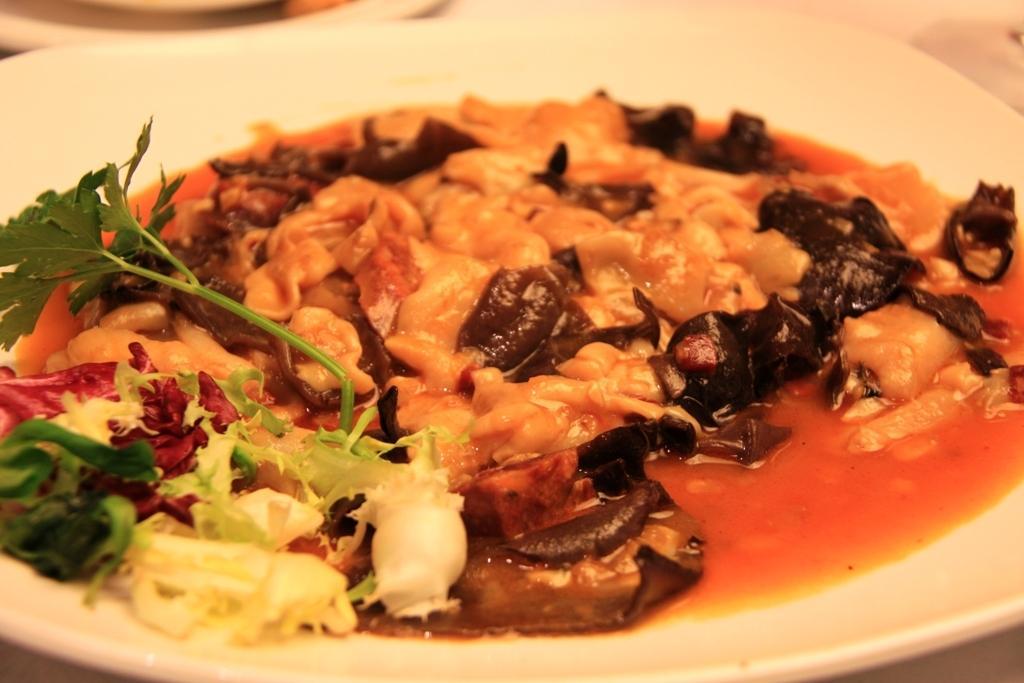Could you give a brief overview of what you see in this image? In the image we can see a plate, white in color. In the latter there are a food item and leaves. 